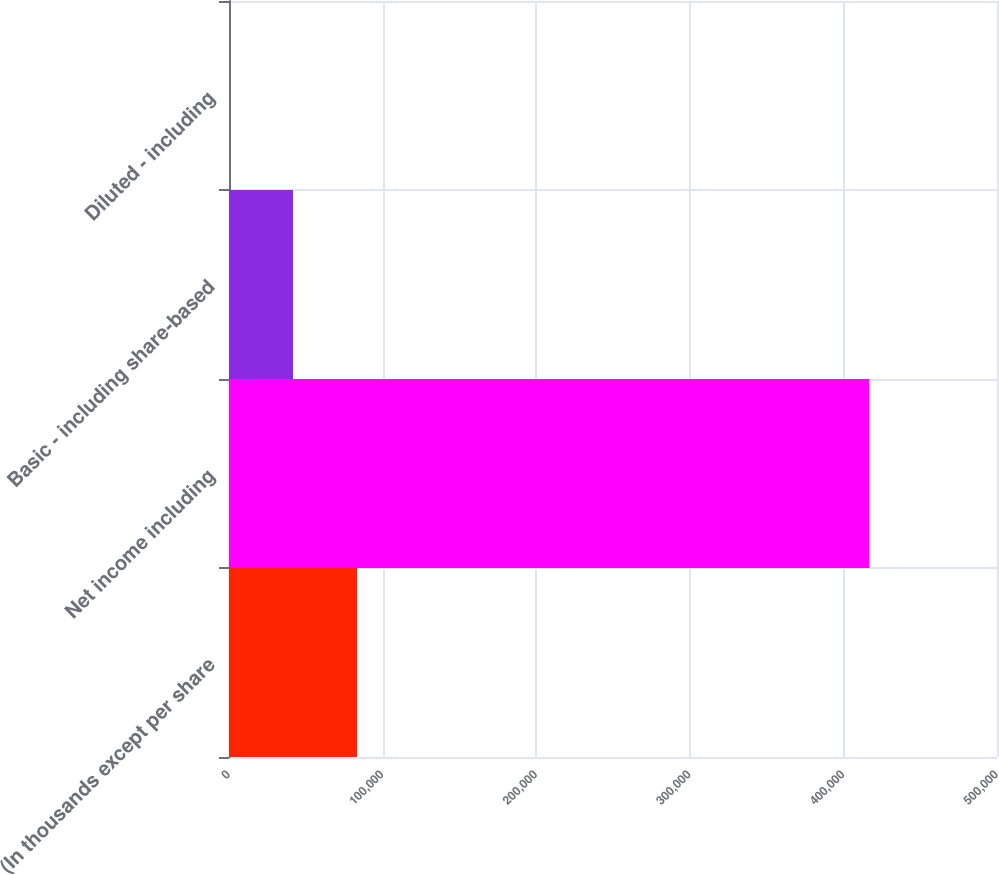Convert chart. <chart><loc_0><loc_0><loc_500><loc_500><bar_chart><fcel>(In thousands except per share<fcel>Net income including<fcel>Basic - including share-based<fcel>Diluted - including<nl><fcel>83393.5<fcel>416963<fcel>41697.3<fcel>1.16<nl></chart> 